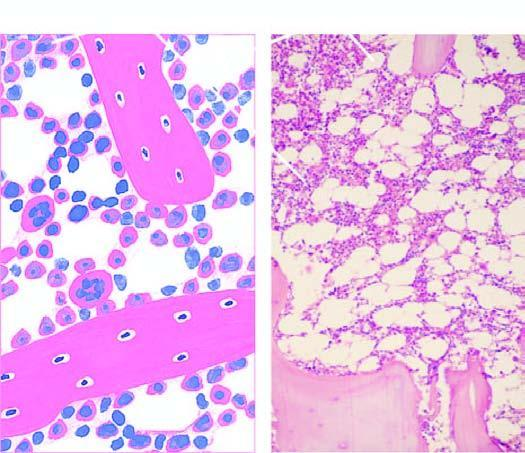do bony trabeculae support the marrow-containing tissue?
Answer the question using a single word or phrase. Yes 